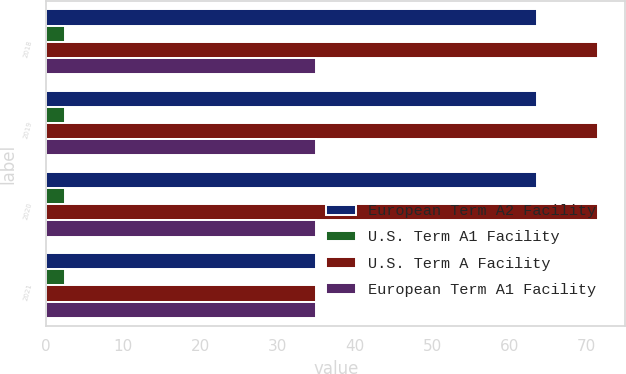Convert chart to OTSL. <chart><loc_0><loc_0><loc_500><loc_500><stacked_bar_chart><ecel><fcel>2018<fcel>2019<fcel>2020<fcel>2021<nl><fcel>European Term A2 Facility<fcel>63.6<fcel>63.6<fcel>63.6<fcel>35<nl><fcel>U.S. Term A1 Facility<fcel>2.4<fcel>2.4<fcel>2.4<fcel>2.4<nl><fcel>U.S. Term A Facility<fcel>71.5<fcel>71.5<fcel>71.5<fcel>35<nl><fcel>European Term A1 Facility<fcel>35<fcel>35<fcel>35<fcel>35<nl></chart> 